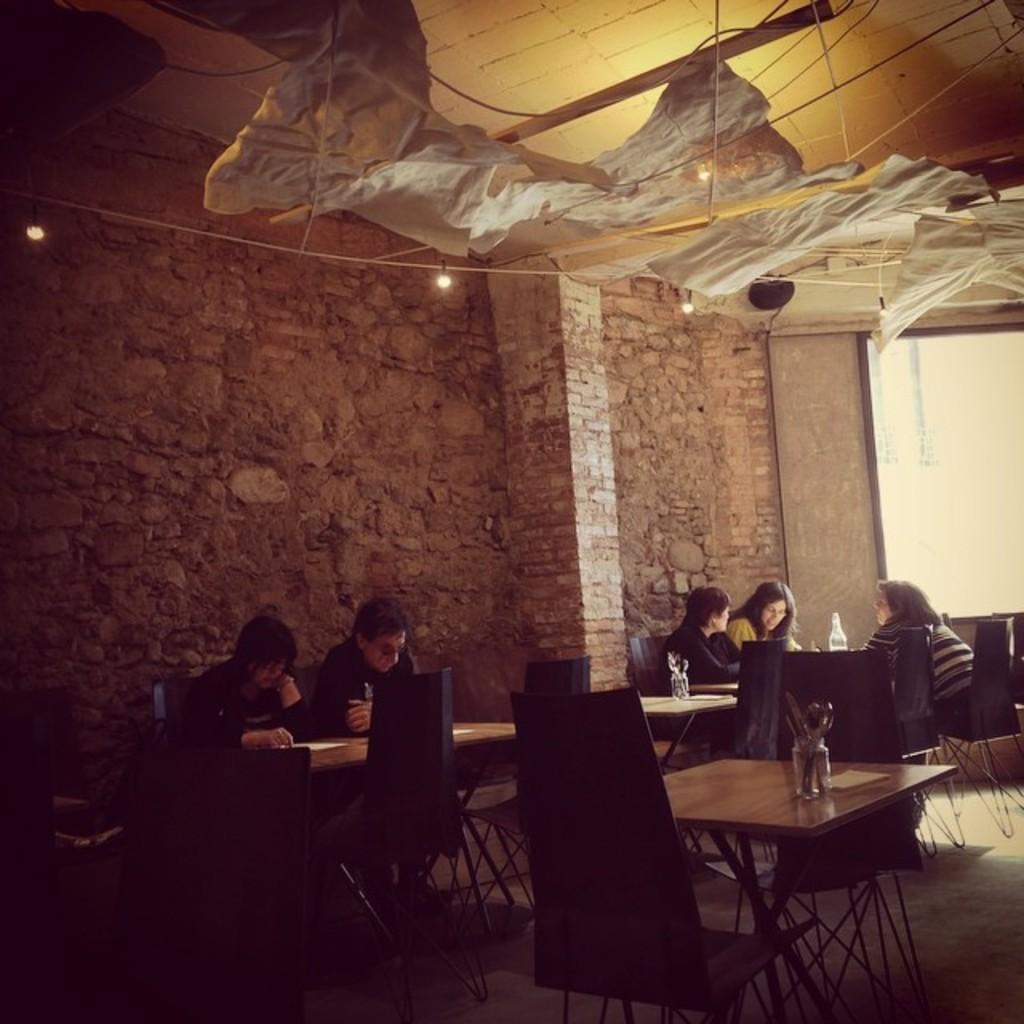What are the people in the image doing? The people in the image are sitting on chairs. What can be seen in the background of the image? There is a brick wall in the background. Are there any gravestones or tombstones visible in the image? No, there are no gravestones or tombstones visible in the image. The image does not depict a cemetery. 